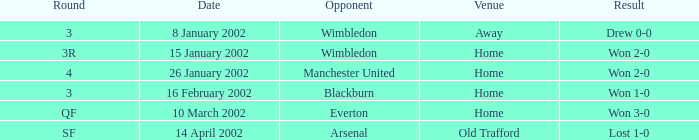What is the rival in a cycle with 3, and a site of home? Blackburn. 